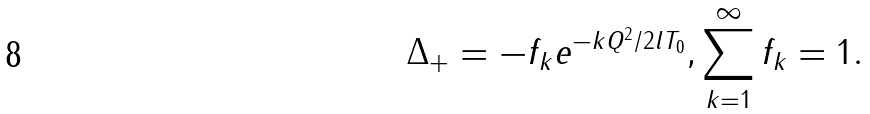<formula> <loc_0><loc_0><loc_500><loc_500>\Delta _ { + } = - f _ { k } e ^ { - k Q ^ { 2 } / 2 l T _ { 0 } } , \sum _ { k = 1 } ^ { \infty } f _ { k } = 1 .</formula> 